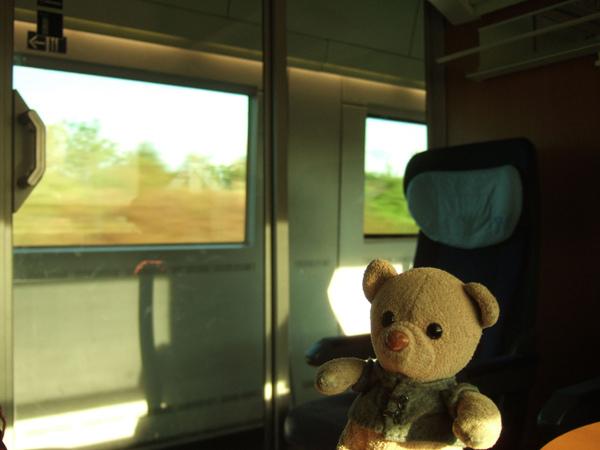Is the teddy bear in a train?
Concise answer only. Yes. How is the bear traveling?
Answer briefly. Train. How many windows is there?
Short answer required. 2. 